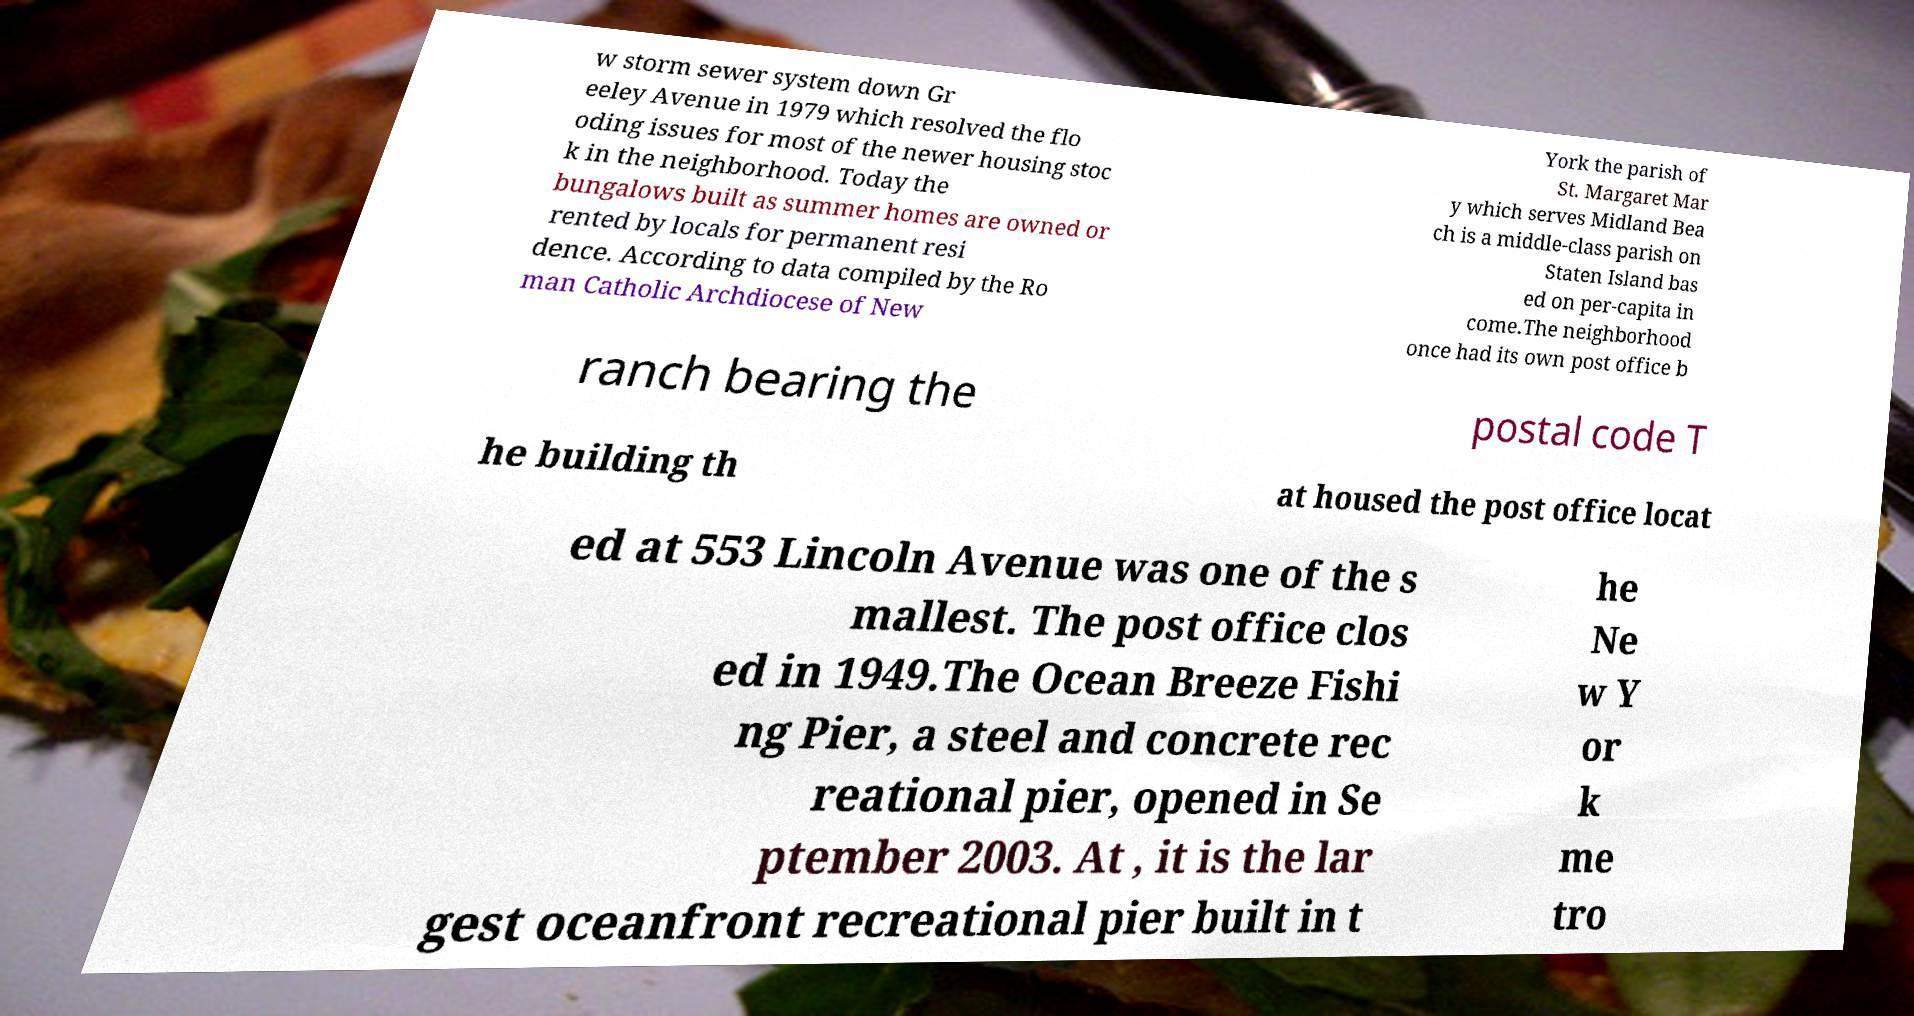Please identify and transcribe the text found in this image. w storm sewer system down Gr eeley Avenue in 1979 which resolved the flo oding issues for most of the newer housing stoc k in the neighborhood. Today the bungalows built as summer homes are owned or rented by locals for permanent resi dence. According to data compiled by the Ro man Catholic Archdiocese of New York the parish of St. Margaret Mar y which serves Midland Bea ch is a middle-class parish on Staten Island bas ed on per-capita in come.The neighborhood once had its own post office b ranch bearing the postal code T he building th at housed the post office locat ed at 553 Lincoln Avenue was one of the s mallest. The post office clos ed in 1949.The Ocean Breeze Fishi ng Pier, a steel and concrete rec reational pier, opened in Se ptember 2003. At , it is the lar gest oceanfront recreational pier built in t he Ne w Y or k me tro 